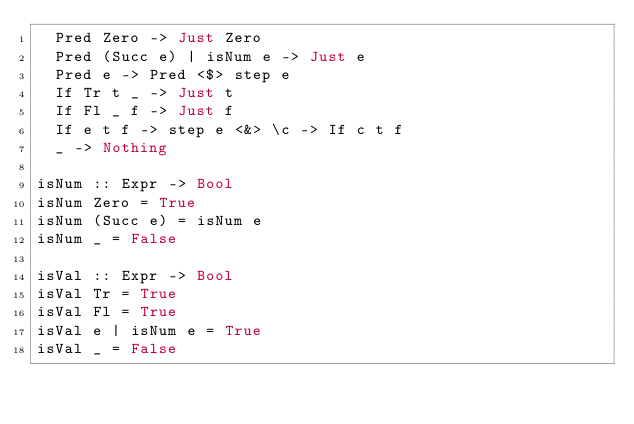Convert code to text. <code><loc_0><loc_0><loc_500><loc_500><_Haskell_>  Pred Zero -> Just Zero
  Pred (Succ e) | isNum e -> Just e
  Pred e -> Pred <$> step e
  If Tr t _ -> Just t
  If Fl _ f -> Just f
  If e t f -> step e <&> \c -> If c t f
  _ -> Nothing

isNum :: Expr -> Bool
isNum Zero = True
isNum (Succ e) = isNum e
isNum _ = False

isVal :: Expr -> Bool
isVal Tr = True
isVal Fl = True
isVal e | isNum e = True
isVal _ = False
</code> 